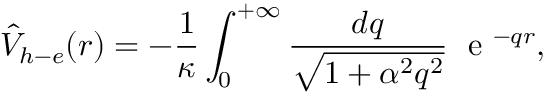Convert formula to latex. <formula><loc_0><loc_0><loc_500><loc_500>{ \hat { V } } _ { h - e } ( r ) = - \frac { 1 } { \kappa } \int _ { 0 } ^ { + \infty } \frac { d q } { \sqrt { 1 + \alpha ^ { 2 } q ^ { 2 } } } \, e ^ { - q r } ,</formula> 